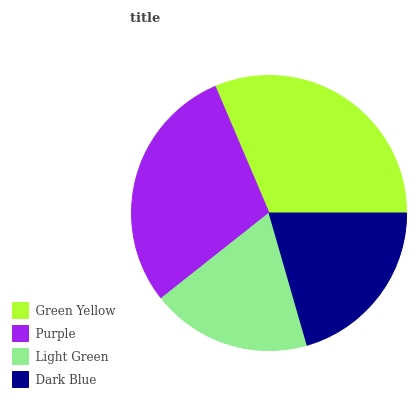Is Light Green the minimum?
Answer yes or no. Yes. Is Green Yellow the maximum?
Answer yes or no. Yes. Is Purple the minimum?
Answer yes or no. No. Is Purple the maximum?
Answer yes or no. No. Is Green Yellow greater than Purple?
Answer yes or no. Yes. Is Purple less than Green Yellow?
Answer yes or no. Yes. Is Purple greater than Green Yellow?
Answer yes or no. No. Is Green Yellow less than Purple?
Answer yes or no. No. Is Purple the high median?
Answer yes or no. Yes. Is Dark Blue the low median?
Answer yes or no. Yes. Is Green Yellow the high median?
Answer yes or no. No. Is Purple the low median?
Answer yes or no. No. 